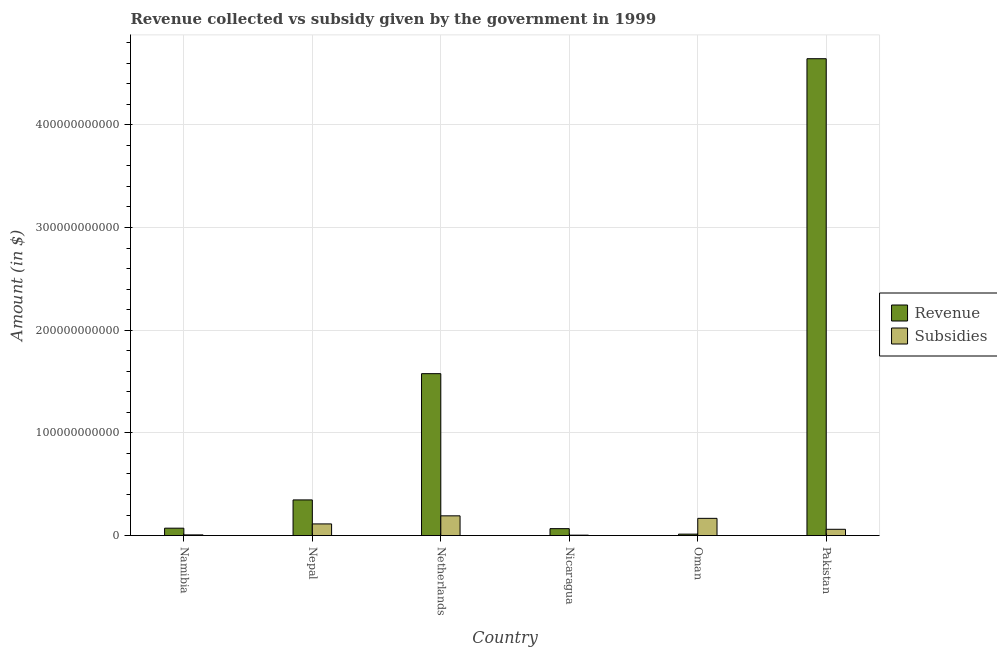How many groups of bars are there?
Make the answer very short. 6. Are the number of bars per tick equal to the number of legend labels?
Make the answer very short. Yes. Are the number of bars on each tick of the X-axis equal?
Provide a succinct answer. Yes. How many bars are there on the 5th tick from the left?
Make the answer very short. 2. What is the label of the 5th group of bars from the left?
Your response must be concise. Oman. What is the amount of subsidies given in Netherlands?
Make the answer very short. 1.92e+1. Across all countries, what is the maximum amount of subsidies given?
Your answer should be compact. 1.92e+1. Across all countries, what is the minimum amount of revenue collected?
Offer a terse response. 1.39e+09. In which country was the amount of revenue collected minimum?
Your answer should be compact. Oman. What is the total amount of subsidies given in the graph?
Make the answer very short. 5.45e+1. What is the difference between the amount of subsidies given in Nicaragua and that in Oman?
Your response must be concise. -1.64e+1. What is the difference between the amount of revenue collected in Netherlands and the amount of subsidies given in Nepal?
Provide a succinct answer. 1.46e+11. What is the average amount of revenue collected per country?
Provide a short and direct response. 1.12e+11. What is the difference between the amount of revenue collected and amount of subsidies given in Namibia?
Provide a short and direct response. 6.53e+09. In how many countries, is the amount of revenue collected greater than 140000000000 $?
Give a very brief answer. 2. What is the ratio of the amount of subsidies given in Nicaragua to that in Pakistan?
Your response must be concise. 0.07. Is the amount of subsidies given in Nepal less than that in Pakistan?
Provide a succinct answer. No. Is the difference between the amount of subsidies given in Namibia and Oman greater than the difference between the amount of revenue collected in Namibia and Oman?
Your answer should be compact. No. What is the difference between the highest and the second highest amount of subsidies given?
Your response must be concise. 2.45e+09. What is the difference between the highest and the lowest amount of revenue collected?
Your answer should be compact. 4.63e+11. What does the 2nd bar from the left in Namibia represents?
Provide a succinct answer. Subsidies. What does the 1st bar from the right in Pakistan represents?
Offer a very short reply. Subsidies. How many bars are there?
Offer a terse response. 12. How many countries are there in the graph?
Provide a short and direct response. 6. What is the difference between two consecutive major ticks on the Y-axis?
Offer a terse response. 1.00e+11. Are the values on the major ticks of Y-axis written in scientific E-notation?
Provide a succinct answer. No. Does the graph contain grids?
Provide a short and direct response. Yes. What is the title of the graph?
Offer a terse response. Revenue collected vs subsidy given by the government in 1999. Does "International Visitors" appear as one of the legend labels in the graph?
Provide a succinct answer. No. What is the label or title of the X-axis?
Provide a succinct answer. Country. What is the label or title of the Y-axis?
Provide a succinct answer. Amount (in $). What is the Amount (in $) in Revenue in Namibia?
Offer a terse response. 7.18e+09. What is the Amount (in $) of Subsidies in Namibia?
Your answer should be very brief. 6.56e+08. What is the Amount (in $) in Revenue in Nepal?
Your response must be concise. 3.47e+1. What is the Amount (in $) of Subsidies in Nepal?
Your answer should be very brief. 1.13e+1. What is the Amount (in $) in Revenue in Netherlands?
Ensure brevity in your answer.  1.58e+11. What is the Amount (in $) in Subsidies in Netherlands?
Your answer should be very brief. 1.92e+1. What is the Amount (in $) of Revenue in Nicaragua?
Your answer should be compact. 6.73e+09. What is the Amount (in $) in Subsidies in Nicaragua?
Offer a very short reply. 3.99e+08. What is the Amount (in $) of Revenue in Oman?
Keep it short and to the point. 1.39e+09. What is the Amount (in $) in Subsidies in Oman?
Make the answer very short. 1.68e+1. What is the Amount (in $) in Revenue in Pakistan?
Your response must be concise. 4.64e+11. What is the Amount (in $) of Subsidies in Pakistan?
Your answer should be compact. 6.11e+09. Across all countries, what is the maximum Amount (in $) in Revenue?
Offer a terse response. 4.64e+11. Across all countries, what is the maximum Amount (in $) of Subsidies?
Offer a terse response. 1.92e+1. Across all countries, what is the minimum Amount (in $) of Revenue?
Offer a very short reply. 1.39e+09. Across all countries, what is the minimum Amount (in $) in Subsidies?
Keep it short and to the point. 3.99e+08. What is the total Amount (in $) in Revenue in the graph?
Offer a terse response. 6.72e+11. What is the total Amount (in $) of Subsidies in the graph?
Offer a terse response. 5.45e+1. What is the difference between the Amount (in $) in Revenue in Namibia and that in Nepal?
Offer a terse response. -2.75e+1. What is the difference between the Amount (in $) in Subsidies in Namibia and that in Nepal?
Offer a terse response. -1.07e+1. What is the difference between the Amount (in $) of Revenue in Namibia and that in Netherlands?
Provide a short and direct response. -1.50e+11. What is the difference between the Amount (in $) of Subsidies in Namibia and that in Netherlands?
Your answer should be very brief. -1.86e+1. What is the difference between the Amount (in $) of Revenue in Namibia and that in Nicaragua?
Your answer should be very brief. 4.55e+08. What is the difference between the Amount (in $) in Subsidies in Namibia and that in Nicaragua?
Provide a succinct answer. 2.57e+08. What is the difference between the Amount (in $) of Revenue in Namibia and that in Oman?
Make the answer very short. 5.79e+09. What is the difference between the Amount (in $) of Subsidies in Namibia and that in Oman?
Give a very brief answer. -1.61e+1. What is the difference between the Amount (in $) of Revenue in Namibia and that in Pakistan?
Make the answer very short. -4.57e+11. What is the difference between the Amount (in $) in Subsidies in Namibia and that in Pakistan?
Your answer should be compact. -5.45e+09. What is the difference between the Amount (in $) in Revenue in Nepal and that in Netherlands?
Your answer should be very brief. -1.23e+11. What is the difference between the Amount (in $) of Subsidies in Nepal and that in Netherlands?
Make the answer very short. -7.87e+09. What is the difference between the Amount (in $) in Revenue in Nepal and that in Nicaragua?
Your answer should be very brief. 2.80e+1. What is the difference between the Amount (in $) in Subsidies in Nepal and that in Nicaragua?
Offer a terse response. 1.10e+1. What is the difference between the Amount (in $) of Revenue in Nepal and that in Oman?
Offer a terse response. 3.33e+1. What is the difference between the Amount (in $) of Subsidies in Nepal and that in Oman?
Ensure brevity in your answer.  -5.41e+09. What is the difference between the Amount (in $) of Revenue in Nepal and that in Pakistan?
Your response must be concise. -4.30e+11. What is the difference between the Amount (in $) in Subsidies in Nepal and that in Pakistan?
Your answer should be compact. 5.24e+09. What is the difference between the Amount (in $) of Revenue in Netherlands and that in Nicaragua?
Ensure brevity in your answer.  1.51e+11. What is the difference between the Amount (in $) in Subsidies in Netherlands and that in Nicaragua?
Offer a very short reply. 1.88e+1. What is the difference between the Amount (in $) of Revenue in Netherlands and that in Oman?
Keep it short and to the point. 1.56e+11. What is the difference between the Amount (in $) of Subsidies in Netherlands and that in Oman?
Make the answer very short. 2.45e+09. What is the difference between the Amount (in $) of Revenue in Netherlands and that in Pakistan?
Your response must be concise. -3.07e+11. What is the difference between the Amount (in $) in Subsidies in Netherlands and that in Pakistan?
Offer a very short reply. 1.31e+1. What is the difference between the Amount (in $) of Revenue in Nicaragua and that in Oman?
Ensure brevity in your answer.  5.34e+09. What is the difference between the Amount (in $) of Subsidies in Nicaragua and that in Oman?
Your answer should be very brief. -1.64e+1. What is the difference between the Amount (in $) in Revenue in Nicaragua and that in Pakistan?
Ensure brevity in your answer.  -4.58e+11. What is the difference between the Amount (in $) in Subsidies in Nicaragua and that in Pakistan?
Ensure brevity in your answer.  -5.71e+09. What is the difference between the Amount (in $) in Revenue in Oman and that in Pakistan?
Your answer should be compact. -4.63e+11. What is the difference between the Amount (in $) in Subsidies in Oman and that in Pakistan?
Your answer should be compact. 1.07e+1. What is the difference between the Amount (in $) of Revenue in Namibia and the Amount (in $) of Subsidies in Nepal?
Give a very brief answer. -4.16e+09. What is the difference between the Amount (in $) of Revenue in Namibia and the Amount (in $) of Subsidies in Netherlands?
Offer a terse response. -1.20e+1. What is the difference between the Amount (in $) of Revenue in Namibia and the Amount (in $) of Subsidies in Nicaragua?
Make the answer very short. 6.79e+09. What is the difference between the Amount (in $) of Revenue in Namibia and the Amount (in $) of Subsidies in Oman?
Your answer should be very brief. -9.58e+09. What is the difference between the Amount (in $) in Revenue in Namibia and the Amount (in $) in Subsidies in Pakistan?
Your answer should be compact. 1.08e+09. What is the difference between the Amount (in $) in Revenue in Nepal and the Amount (in $) in Subsidies in Netherlands?
Provide a short and direct response. 1.55e+1. What is the difference between the Amount (in $) in Revenue in Nepal and the Amount (in $) in Subsidies in Nicaragua?
Your answer should be very brief. 3.43e+1. What is the difference between the Amount (in $) of Revenue in Nepal and the Amount (in $) of Subsidies in Oman?
Ensure brevity in your answer.  1.79e+1. What is the difference between the Amount (in $) of Revenue in Nepal and the Amount (in $) of Subsidies in Pakistan?
Your answer should be very brief. 2.86e+1. What is the difference between the Amount (in $) in Revenue in Netherlands and the Amount (in $) in Subsidies in Nicaragua?
Provide a short and direct response. 1.57e+11. What is the difference between the Amount (in $) of Revenue in Netherlands and the Amount (in $) of Subsidies in Oman?
Give a very brief answer. 1.41e+11. What is the difference between the Amount (in $) of Revenue in Netherlands and the Amount (in $) of Subsidies in Pakistan?
Provide a succinct answer. 1.52e+11. What is the difference between the Amount (in $) of Revenue in Nicaragua and the Amount (in $) of Subsidies in Oman?
Make the answer very short. -1.00e+1. What is the difference between the Amount (in $) of Revenue in Nicaragua and the Amount (in $) of Subsidies in Pakistan?
Ensure brevity in your answer.  6.23e+08. What is the difference between the Amount (in $) in Revenue in Oman and the Amount (in $) in Subsidies in Pakistan?
Give a very brief answer. -4.71e+09. What is the average Amount (in $) of Revenue per country?
Offer a terse response. 1.12e+11. What is the average Amount (in $) in Subsidies per country?
Ensure brevity in your answer.  9.08e+09. What is the difference between the Amount (in $) in Revenue and Amount (in $) in Subsidies in Namibia?
Your answer should be very brief. 6.53e+09. What is the difference between the Amount (in $) of Revenue and Amount (in $) of Subsidies in Nepal?
Your response must be concise. 2.34e+1. What is the difference between the Amount (in $) of Revenue and Amount (in $) of Subsidies in Netherlands?
Keep it short and to the point. 1.38e+11. What is the difference between the Amount (in $) in Revenue and Amount (in $) in Subsidies in Nicaragua?
Ensure brevity in your answer.  6.33e+09. What is the difference between the Amount (in $) in Revenue and Amount (in $) in Subsidies in Oman?
Your answer should be compact. -1.54e+1. What is the difference between the Amount (in $) in Revenue and Amount (in $) in Subsidies in Pakistan?
Ensure brevity in your answer.  4.58e+11. What is the ratio of the Amount (in $) in Revenue in Namibia to that in Nepal?
Keep it short and to the point. 0.21. What is the ratio of the Amount (in $) of Subsidies in Namibia to that in Nepal?
Keep it short and to the point. 0.06. What is the ratio of the Amount (in $) in Revenue in Namibia to that in Netherlands?
Give a very brief answer. 0.05. What is the ratio of the Amount (in $) of Subsidies in Namibia to that in Netherlands?
Give a very brief answer. 0.03. What is the ratio of the Amount (in $) in Revenue in Namibia to that in Nicaragua?
Provide a succinct answer. 1.07. What is the ratio of the Amount (in $) of Subsidies in Namibia to that in Nicaragua?
Your answer should be compact. 1.64. What is the ratio of the Amount (in $) in Revenue in Namibia to that in Oman?
Offer a very short reply. 5.15. What is the ratio of the Amount (in $) of Subsidies in Namibia to that in Oman?
Ensure brevity in your answer.  0.04. What is the ratio of the Amount (in $) in Revenue in Namibia to that in Pakistan?
Offer a terse response. 0.02. What is the ratio of the Amount (in $) in Subsidies in Namibia to that in Pakistan?
Your answer should be very brief. 0.11. What is the ratio of the Amount (in $) in Revenue in Nepal to that in Netherlands?
Ensure brevity in your answer.  0.22. What is the ratio of the Amount (in $) of Subsidies in Nepal to that in Netherlands?
Ensure brevity in your answer.  0.59. What is the ratio of the Amount (in $) in Revenue in Nepal to that in Nicaragua?
Offer a very short reply. 5.16. What is the ratio of the Amount (in $) of Subsidies in Nepal to that in Nicaragua?
Your response must be concise. 28.47. What is the ratio of the Amount (in $) in Revenue in Nepal to that in Oman?
Provide a succinct answer. 24.89. What is the ratio of the Amount (in $) of Subsidies in Nepal to that in Oman?
Make the answer very short. 0.68. What is the ratio of the Amount (in $) of Revenue in Nepal to that in Pakistan?
Keep it short and to the point. 0.07. What is the ratio of the Amount (in $) in Subsidies in Nepal to that in Pakistan?
Your answer should be compact. 1.86. What is the ratio of the Amount (in $) of Revenue in Netherlands to that in Nicaragua?
Provide a succinct answer. 23.43. What is the ratio of the Amount (in $) in Subsidies in Netherlands to that in Nicaragua?
Keep it short and to the point. 48.2. What is the ratio of the Amount (in $) of Revenue in Netherlands to that in Oman?
Keep it short and to the point. 113.06. What is the ratio of the Amount (in $) of Subsidies in Netherlands to that in Oman?
Provide a succinct answer. 1.15. What is the ratio of the Amount (in $) in Revenue in Netherlands to that in Pakistan?
Your answer should be compact. 0.34. What is the ratio of the Amount (in $) of Subsidies in Netherlands to that in Pakistan?
Give a very brief answer. 3.15. What is the ratio of the Amount (in $) of Revenue in Nicaragua to that in Oman?
Offer a very short reply. 4.83. What is the ratio of the Amount (in $) in Subsidies in Nicaragua to that in Oman?
Offer a terse response. 0.02. What is the ratio of the Amount (in $) in Revenue in Nicaragua to that in Pakistan?
Your answer should be very brief. 0.01. What is the ratio of the Amount (in $) in Subsidies in Nicaragua to that in Pakistan?
Give a very brief answer. 0.07. What is the ratio of the Amount (in $) in Revenue in Oman to that in Pakistan?
Give a very brief answer. 0. What is the ratio of the Amount (in $) in Subsidies in Oman to that in Pakistan?
Ensure brevity in your answer.  2.75. What is the difference between the highest and the second highest Amount (in $) of Revenue?
Ensure brevity in your answer.  3.07e+11. What is the difference between the highest and the second highest Amount (in $) in Subsidies?
Give a very brief answer. 2.45e+09. What is the difference between the highest and the lowest Amount (in $) in Revenue?
Ensure brevity in your answer.  4.63e+11. What is the difference between the highest and the lowest Amount (in $) in Subsidies?
Offer a very short reply. 1.88e+1. 